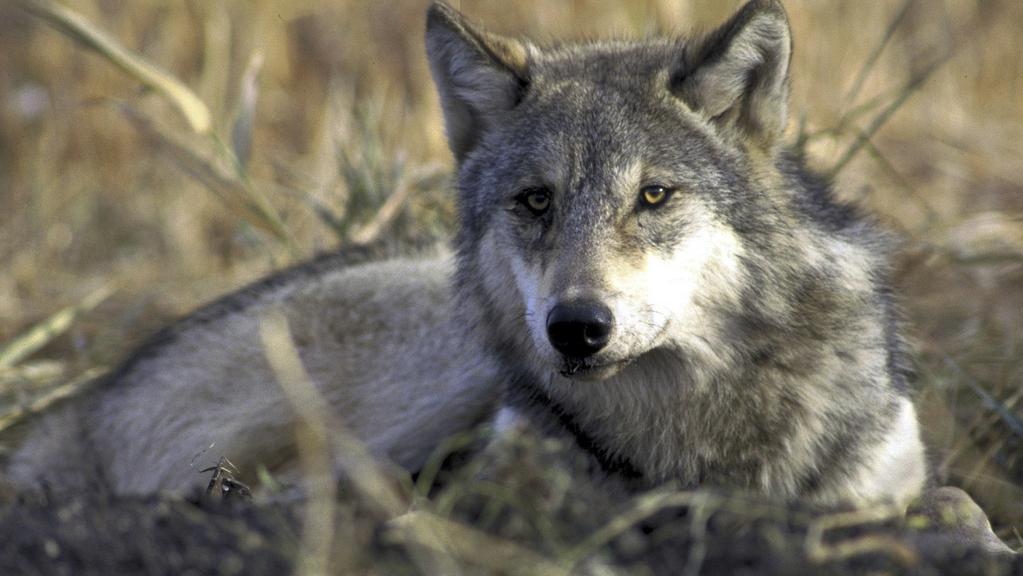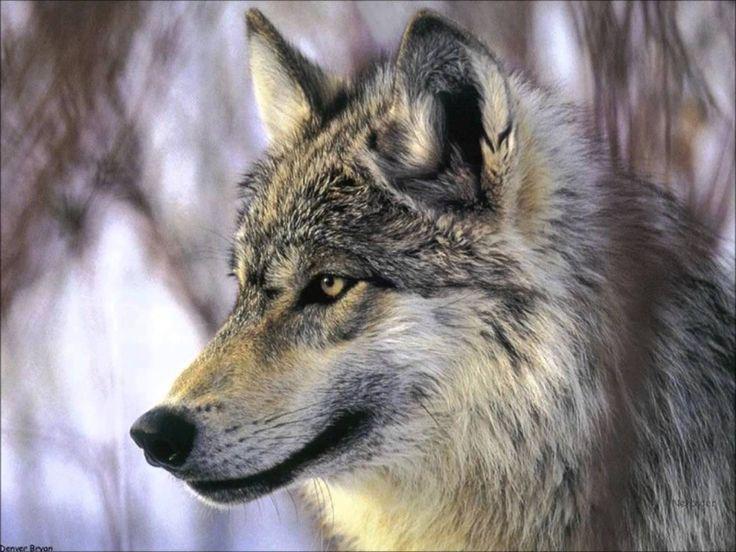The first image is the image on the left, the second image is the image on the right. Analyze the images presented: Is the assertion "An image shows at least one wolf gazing directly leftward." valid? Answer yes or no. Yes. 